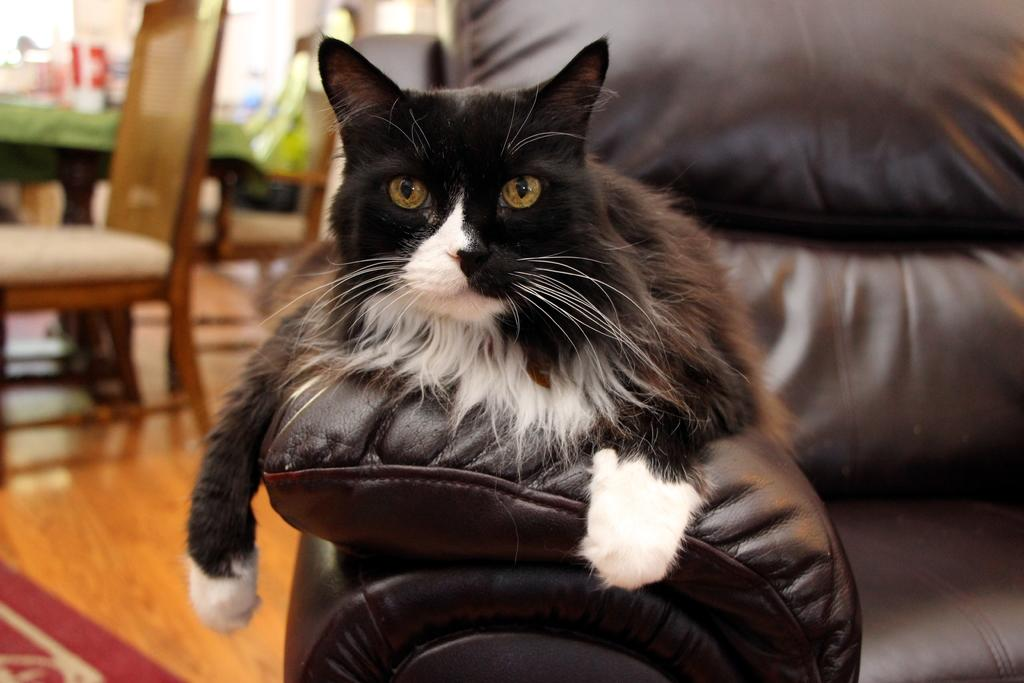What type of animal is in the image? There is a cat in the image. Where is the cat located? The cat is sitting on a couch. What can be seen in the background of the image? There is a wooden table and chairs in the background. What is covering the items on the table? The items placed on a green cloth. What part of the room is visible at the bottom of the image? The floor is visible at the bottom of the image. What type of watch is the cat wearing in the image? There is no watch present in the image; the cat is not wearing any accessories. 